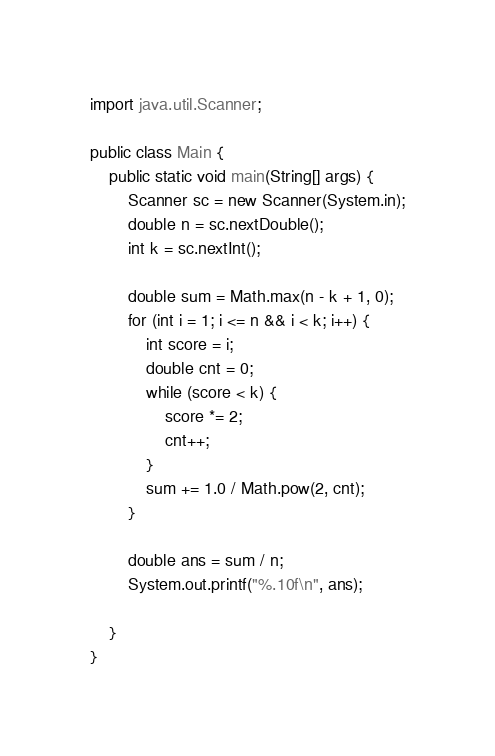<code> <loc_0><loc_0><loc_500><loc_500><_Java_>import java.util.Scanner;

public class Main {
	public static void main(String[] args) {
		Scanner sc = new Scanner(System.in);
		double n = sc.nextDouble();
		int k = sc.nextInt();
		
		double sum = Math.max(n - k + 1, 0);
		for (int i = 1; i <= n && i < k; i++) {
			int score = i;
			double cnt = 0;
			while (score < k) {
				score *= 2;
				cnt++;
			}
			sum += 1.0 / Math.pow(2, cnt);
		}
		
		double ans = sum / n;
		System.out.printf("%.10f\n", ans);

	}
}
</code> 